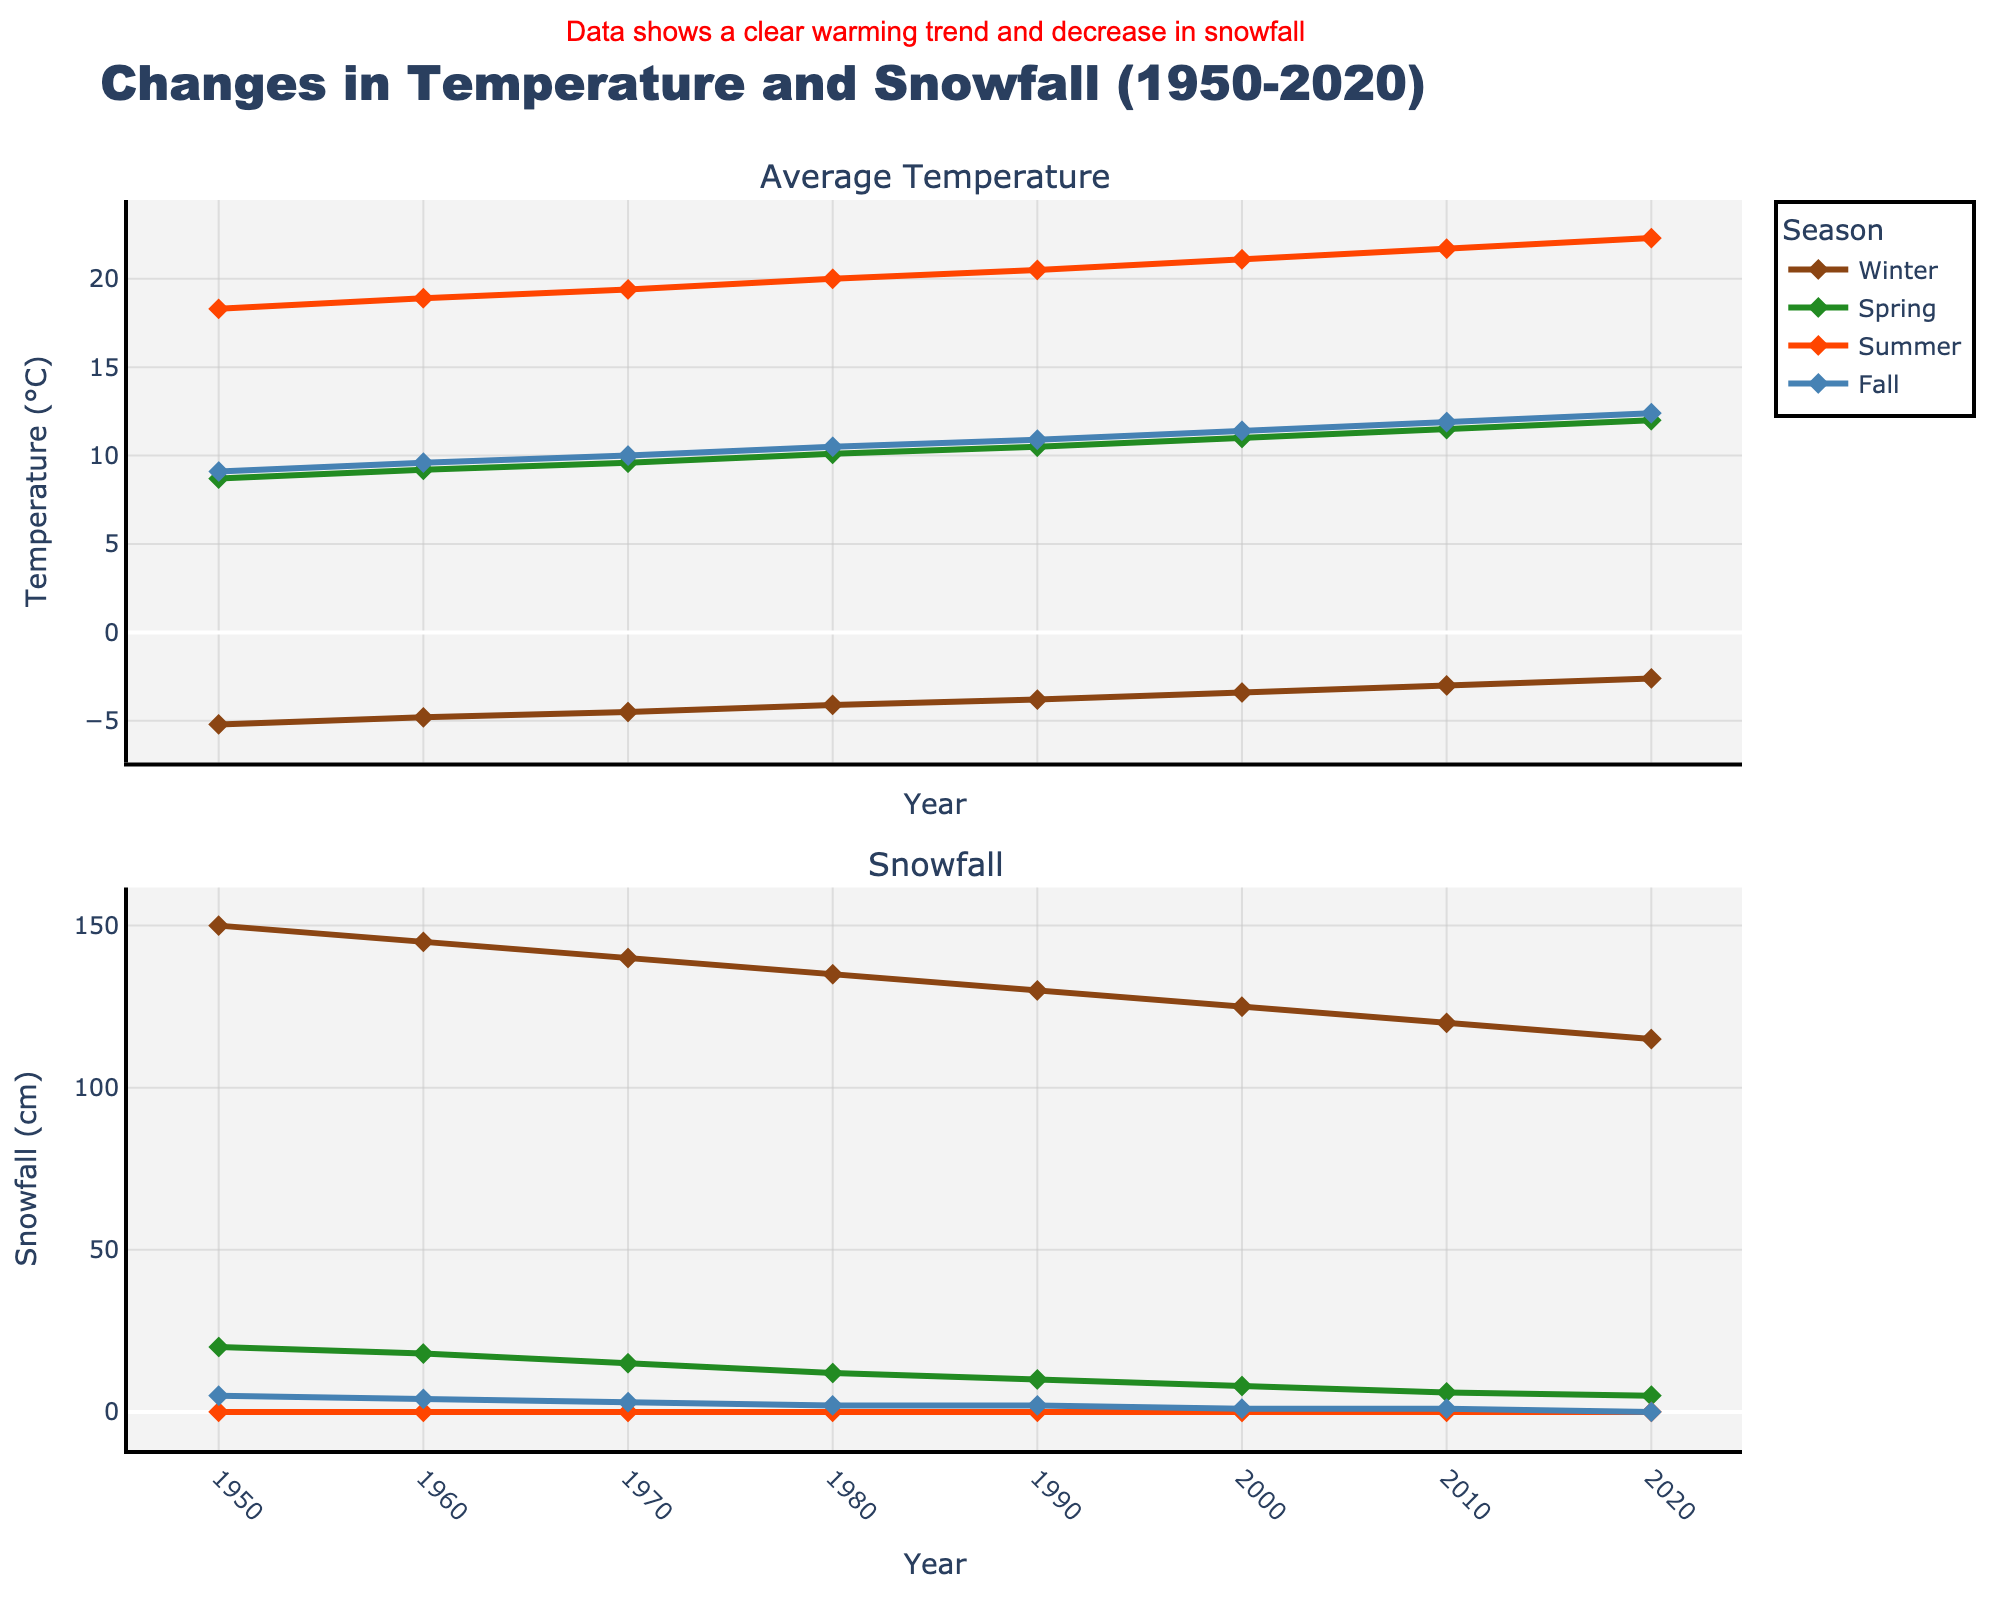What season shows the most significant increase in average temperature from 1950 to 2020? To find this, we look at the difference in average temperature from 1950 to 2020 for each season. For Winter, the increase is (-2.6 - (-5.2)) = 2.6°C; for Spring, it is (12.0 - 8.7) = 3.3°C; for Summer, it is (22.3 - 18.3) = 4.0°C; for Fall, it is (12.4 - 9.1) = 3.3°C. Therefore, Summer shows the most significant increase.
Answer: Summer How has snowfall in Winter changed from 1950 to 2020? We compare the snowfall in Winter for the years 1950 and 2020. In 1950, snowfall was 150 cm, and in 2020, it dropped to 115 cm, showing a significant decrease.
Answer: Decreased Which year showed the highest average temperature in Summer? By examining the Summer plot, we observe the year-wise values. The highest temperature is in 2020 with a value of 22.3°C.
Answer: 2020 In which year did Fall reach an average temperature of 10.0°C? In the plot for Fall temperatures, 1970 shows the point reaching 10.0°C, the first year it reached this value.
Answer: 1970 Compare the average temperature trends in Spring and Fall from 1950 to 2020. Evaluating both Spring and Fall from 1950 to 2020, Spring increases from 8.7°C to 12.0°C, and Fall from 9.1°C to 12.4°C. Both show a rising trend, with a similar increase (Spring: 3.3°C, Fall: 3.3°C).
Answer: Both increased similarly In which season and year did the snowfall drop to 1 cm in Fall? According to the snowfall plot for Fall, the point where snowfall is 1 cm is in the years 2000 and 2010.
Answer: 2000, 2010 What is the difference between the highest and lowest average temperatures recorded in Summer from 1950 to 2020? The highest average temperature in Summer (22.3°C in 2020) and the lowest (18.3°C in 1950). The difference is 22.3 - 18.3 = 4.0°C.
Answer: 4.0°C Which season had the highest snowfall in 1980? Observing the snowfall subplots for 1980, Winter has the highest value with 135 cm.
Answer: Winter 